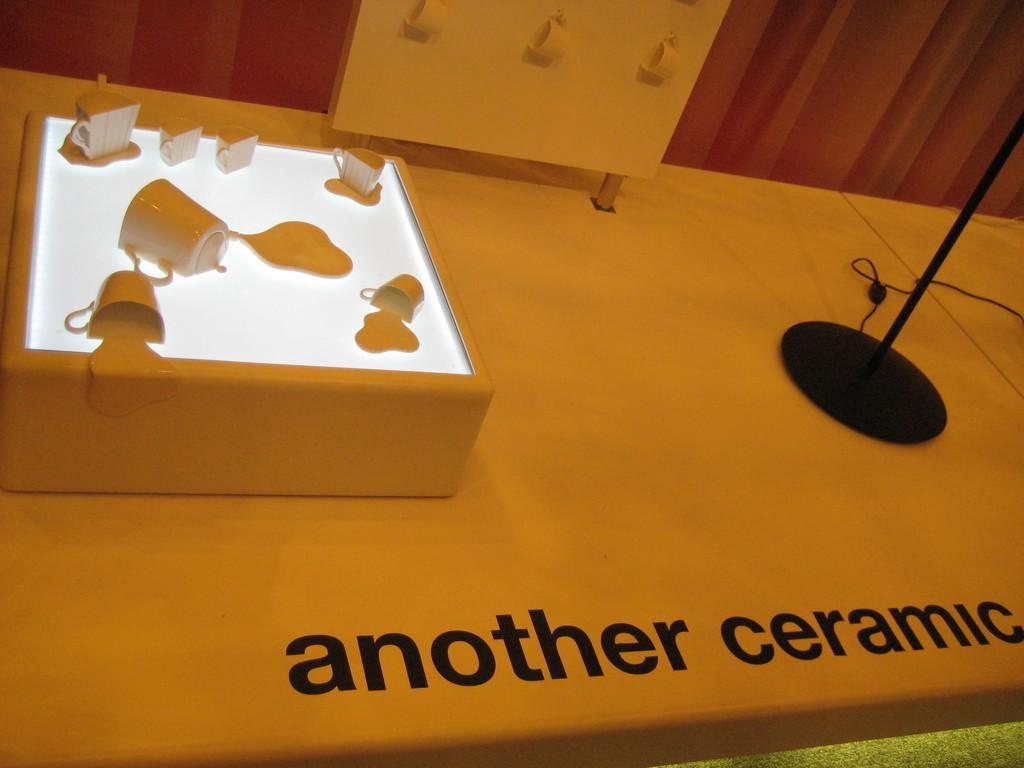<image>
Create a compact narrative representing the image presented. another ceramic art display with coffee cups and mugs 